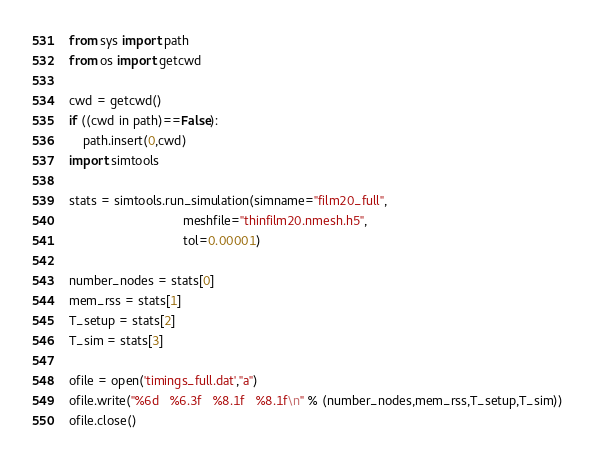Convert code to text. <code><loc_0><loc_0><loc_500><loc_500><_Python_>from sys import path
from os import getcwd

cwd = getcwd()
if ((cwd in path)==False):
    path.insert(0,cwd)
import simtools

stats = simtools.run_simulation(simname="film20_full",
                                meshfile="thinfilm20.nmesh.h5",
                                tol=0.00001)

number_nodes = stats[0]
mem_rss = stats[1]
T_setup = stats[2]
T_sim = stats[3]

ofile = open('timings_full.dat',"a")
ofile.write("%6d   %6.3f   %8.1f   %8.1f\n" % (number_nodes,mem_rss,T_setup,T_sim))
ofile.close()
</code> 